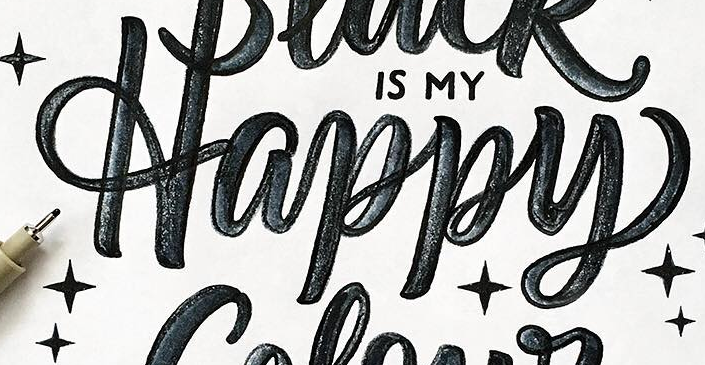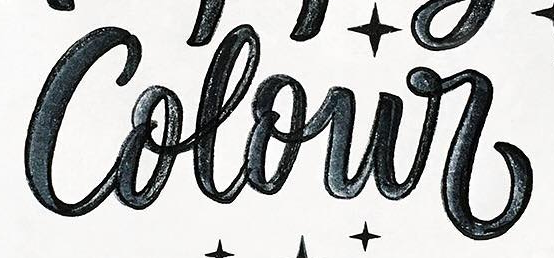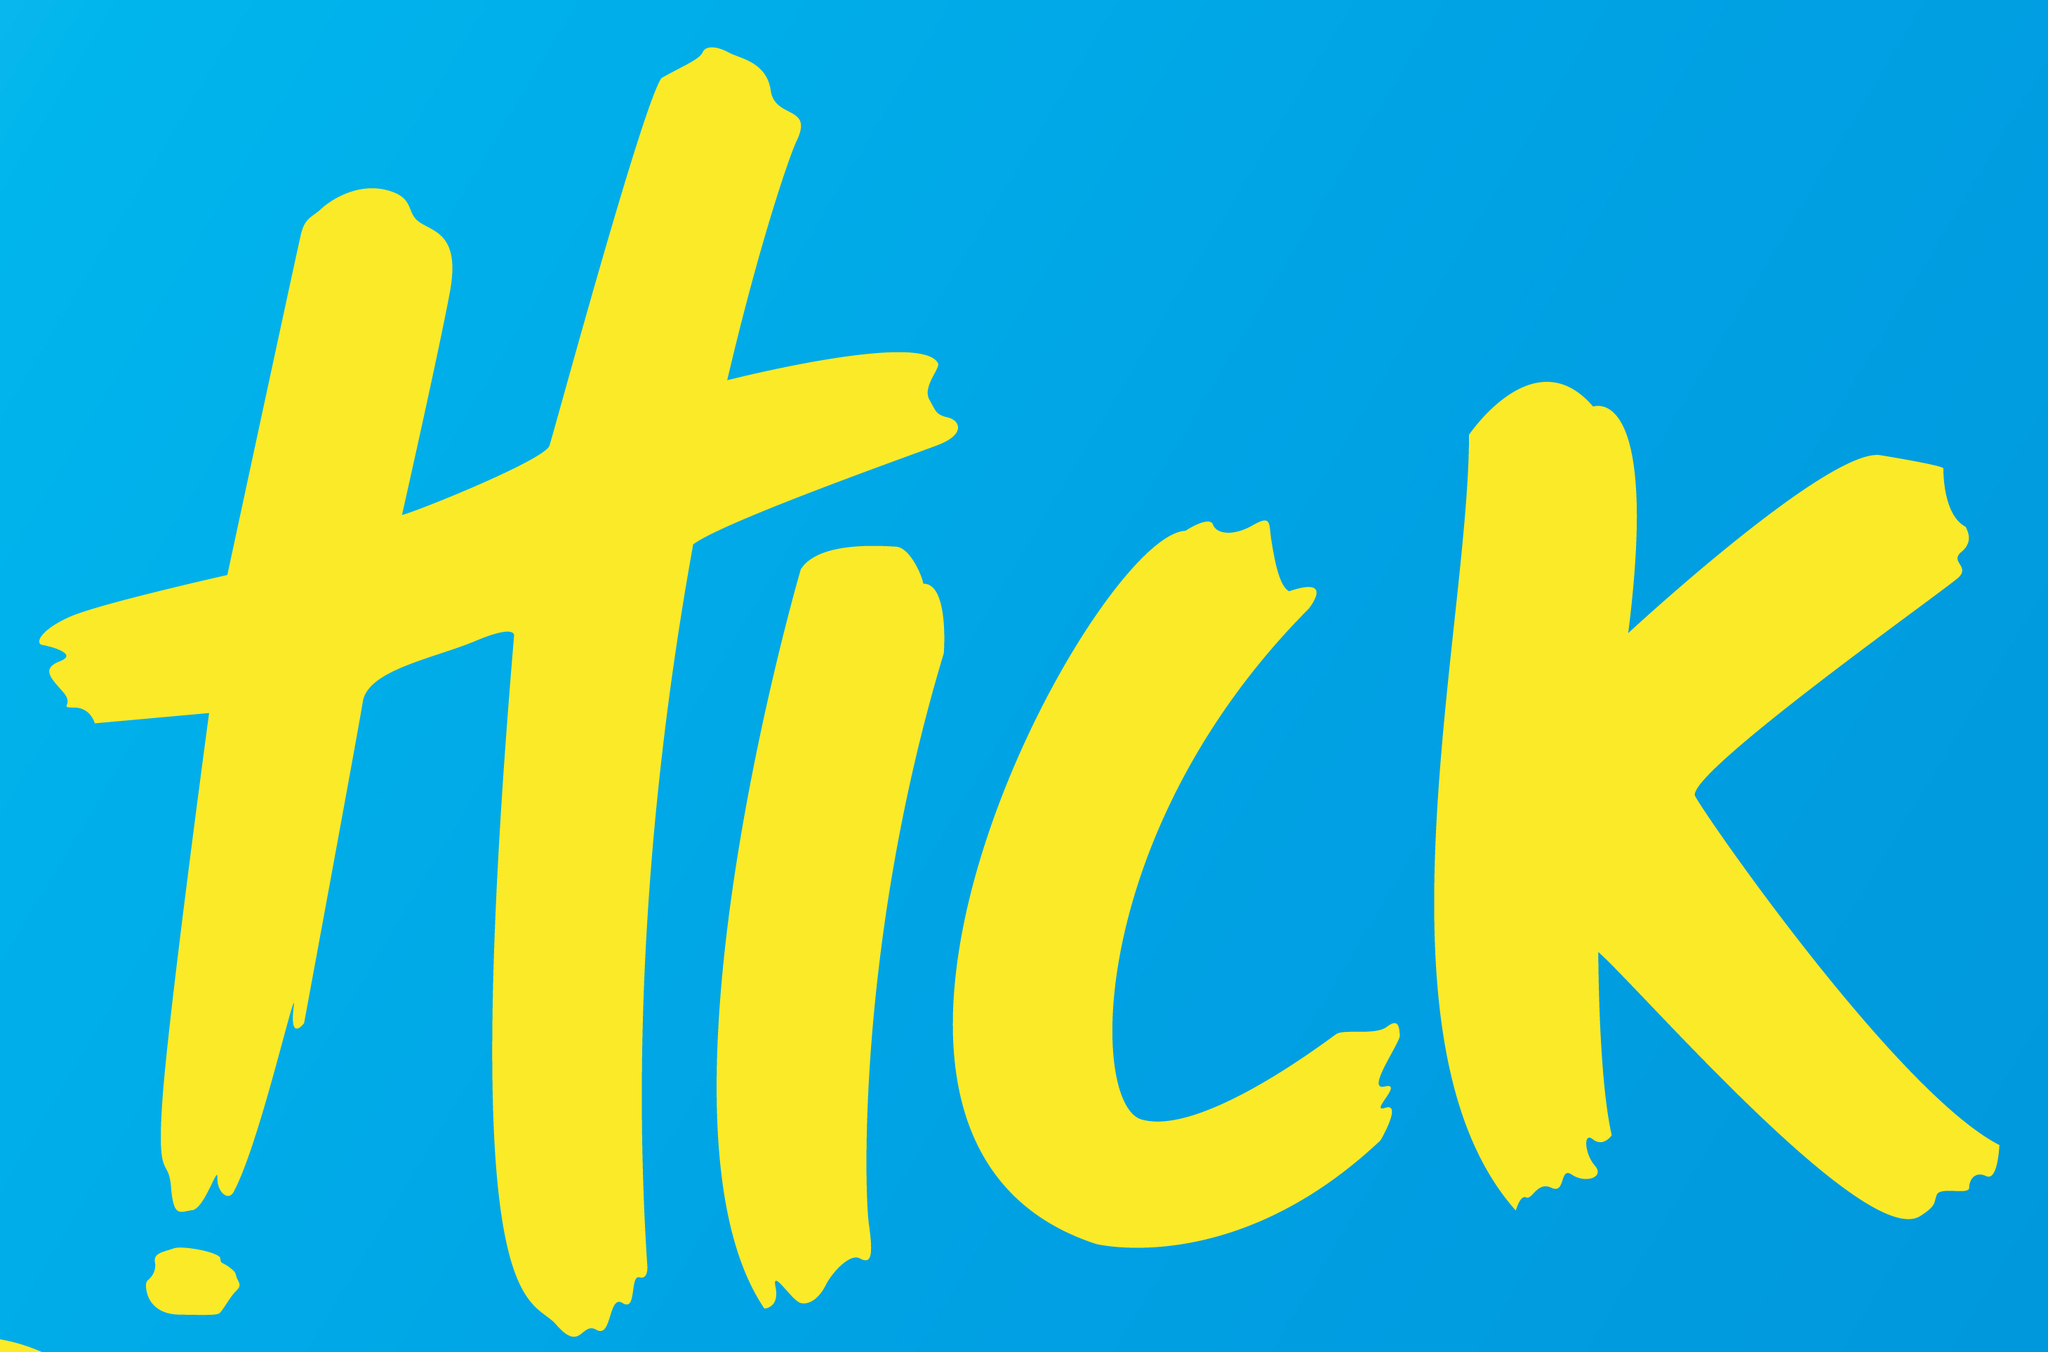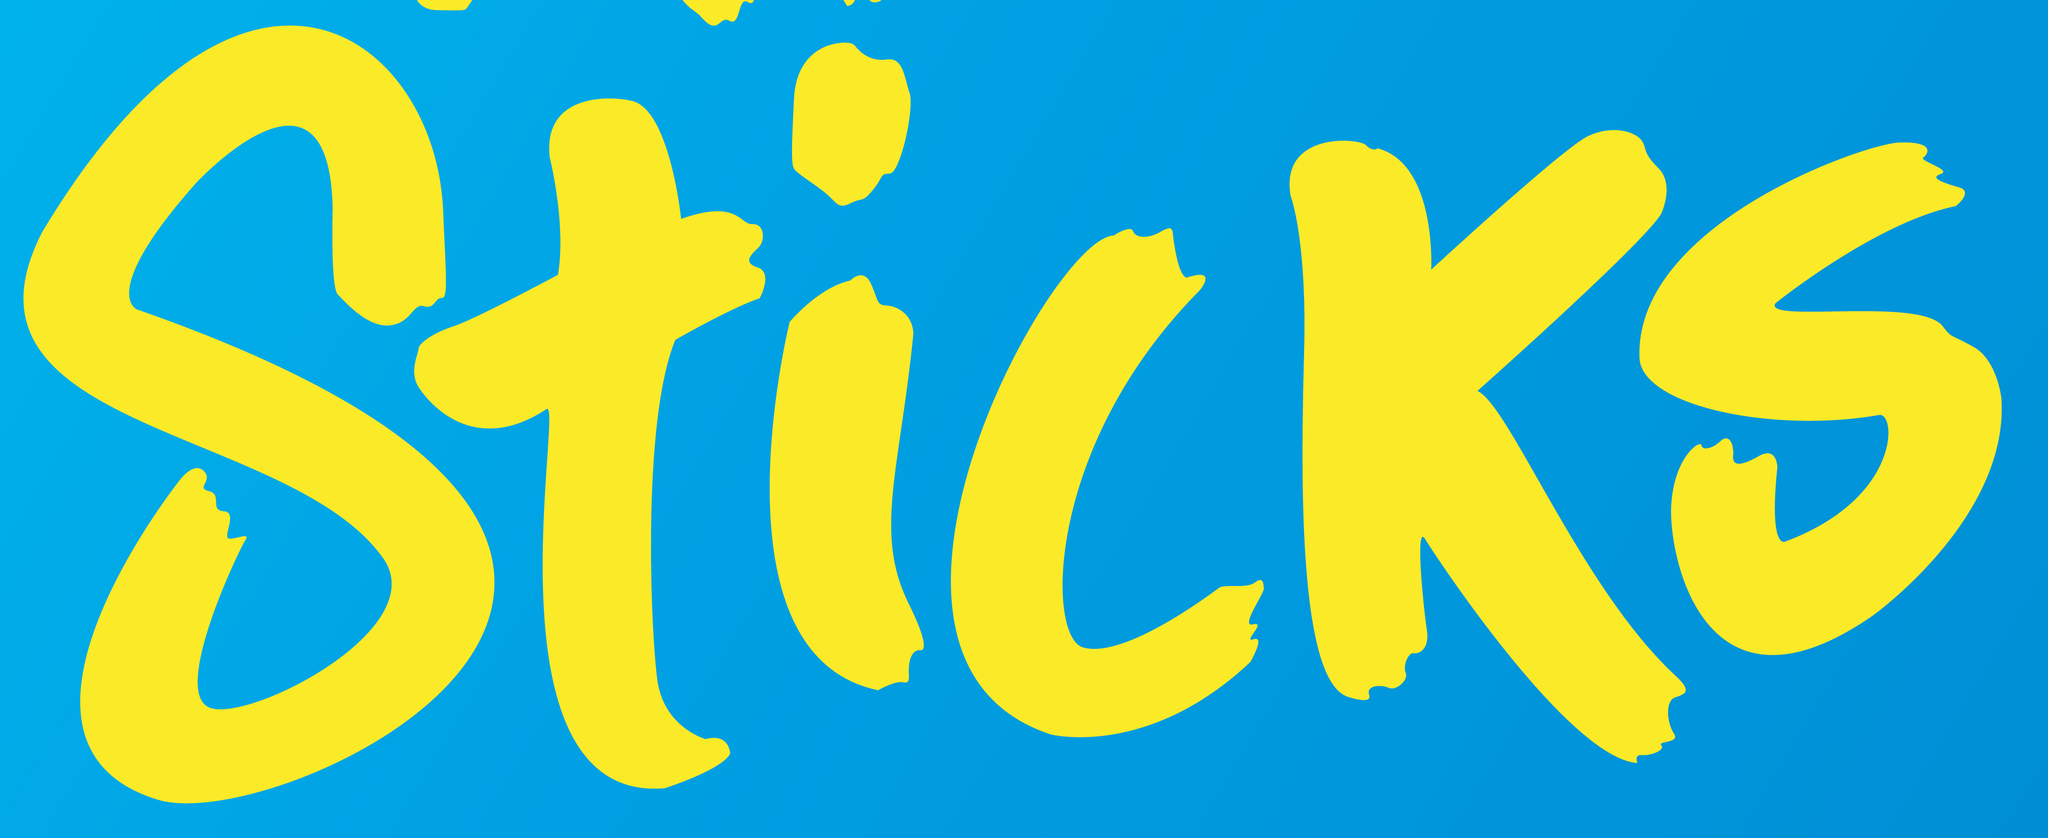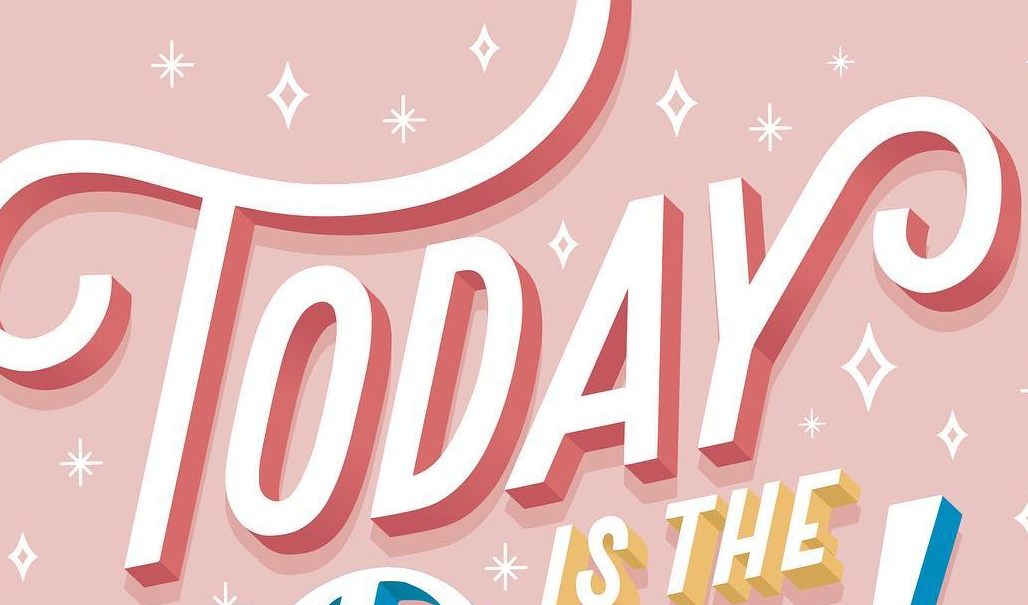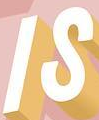Read the text content from these images in order, separated by a semicolon. Happy; Colour; HICK; Sticks; TODAY; IS 